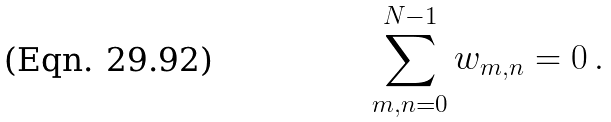Convert formula to latex. <formula><loc_0><loc_0><loc_500><loc_500>\sum _ { m , n = 0 } ^ { N - 1 } w _ { m , n } = 0 \, .</formula> 